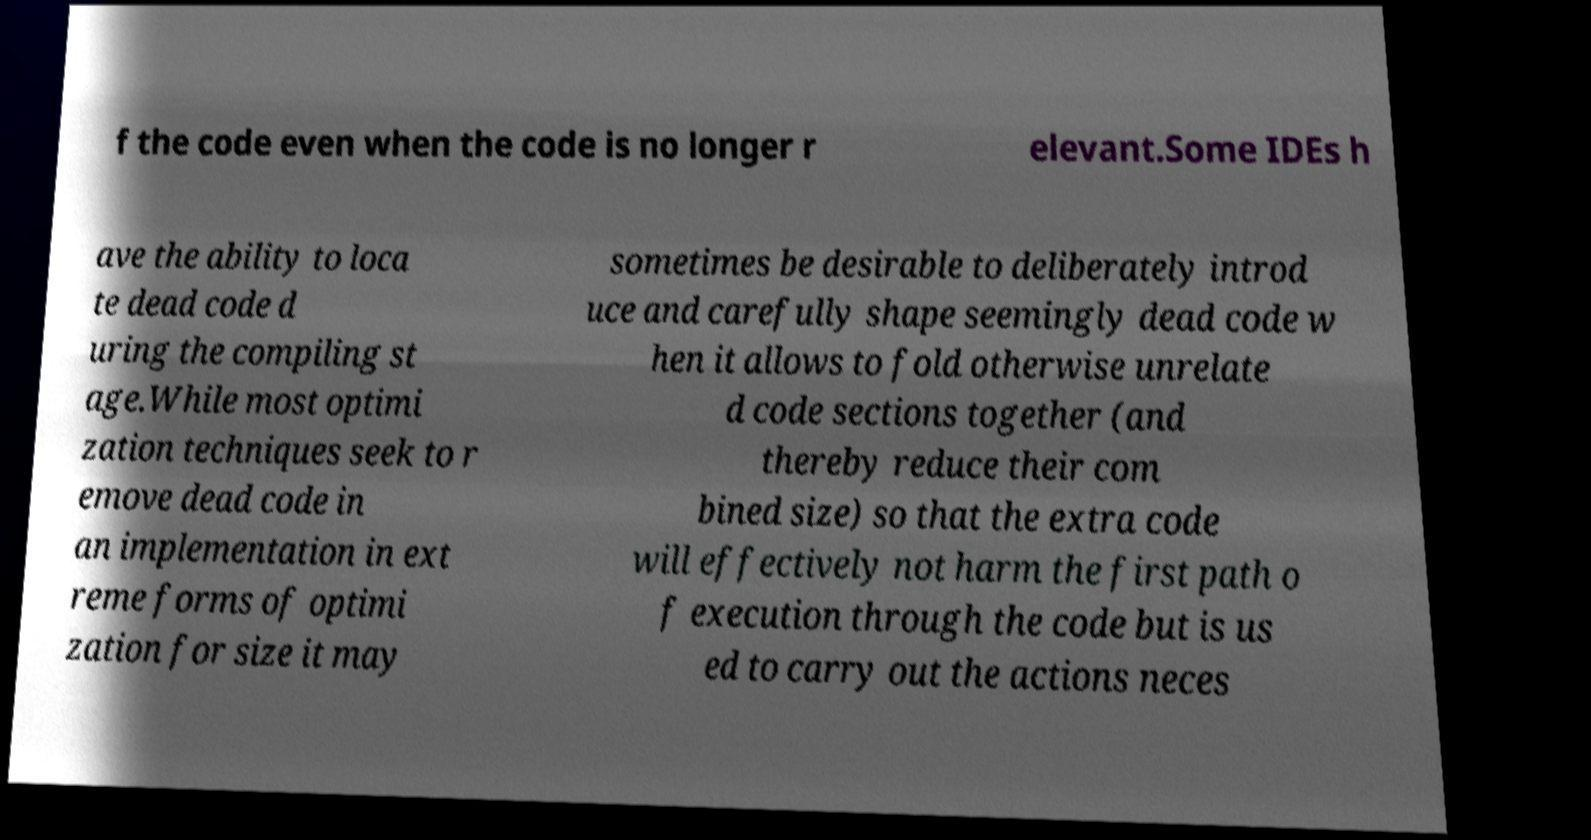Can you accurately transcribe the text from the provided image for me? f the code even when the code is no longer r elevant.Some IDEs h ave the ability to loca te dead code d uring the compiling st age.While most optimi zation techniques seek to r emove dead code in an implementation in ext reme forms of optimi zation for size it may sometimes be desirable to deliberately introd uce and carefully shape seemingly dead code w hen it allows to fold otherwise unrelate d code sections together (and thereby reduce their com bined size) so that the extra code will effectively not harm the first path o f execution through the code but is us ed to carry out the actions neces 